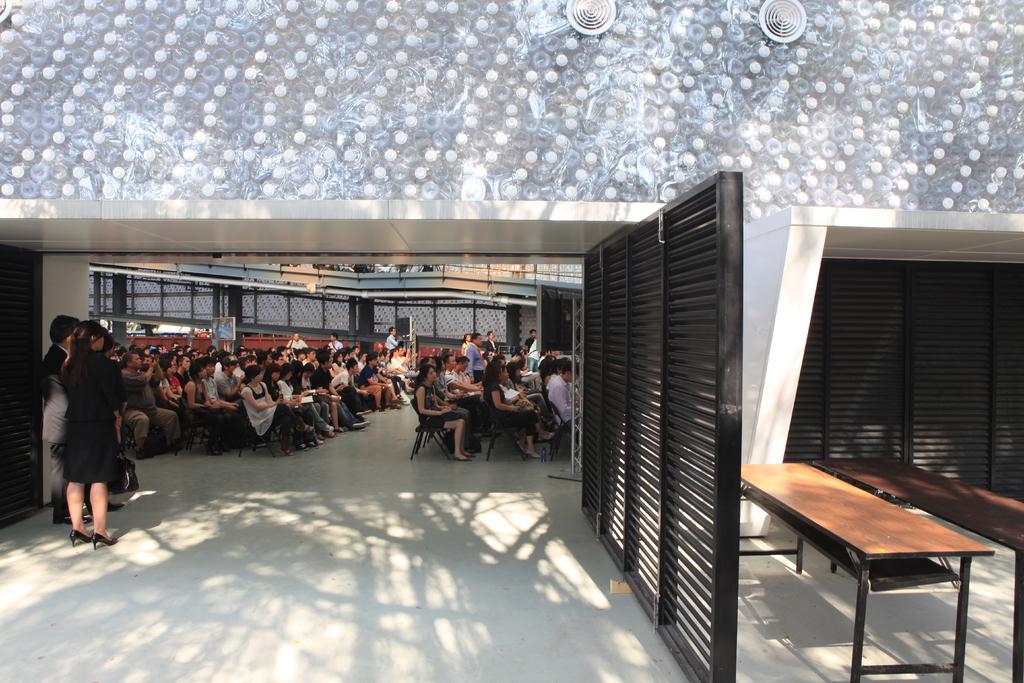Could you give a brief overview of what you see in this image? In this image there are group of persons sitting and standing. On the right side there is a stand which is black in colour and there are tables. 